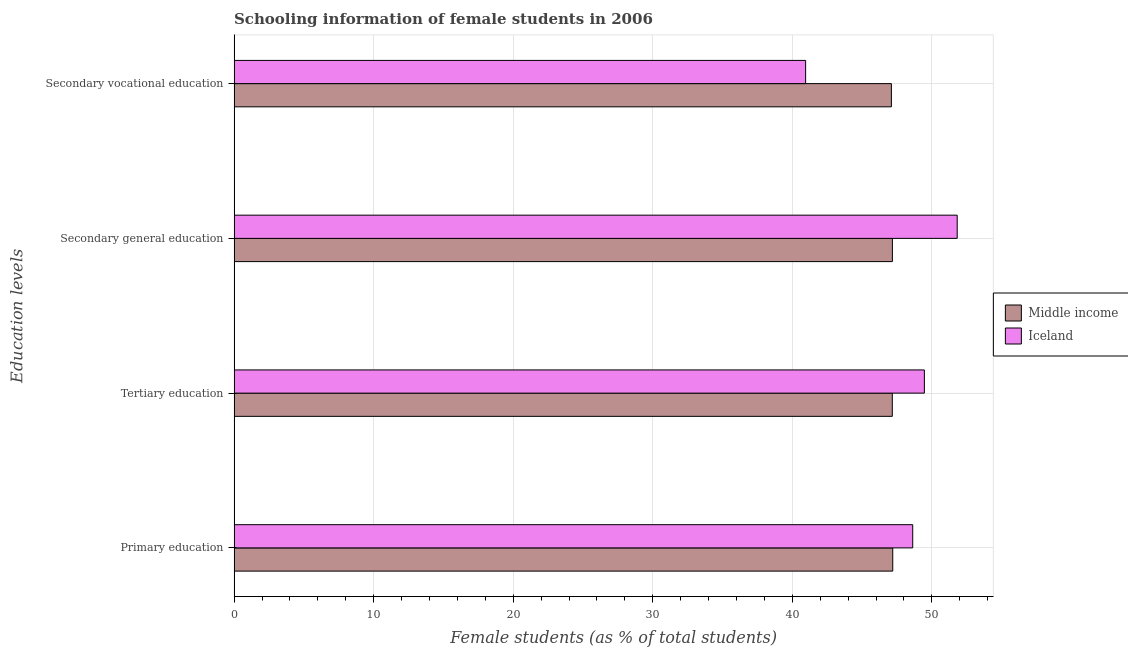How many different coloured bars are there?
Offer a very short reply. 2. Are the number of bars on each tick of the Y-axis equal?
Your answer should be very brief. Yes. How many bars are there on the 2nd tick from the top?
Give a very brief answer. 2. How many bars are there on the 3rd tick from the bottom?
Make the answer very short. 2. What is the percentage of female students in secondary education in Iceland?
Keep it short and to the point. 51.81. Across all countries, what is the maximum percentage of female students in secondary vocational education?
Offer a very short reply. 47.1. Across all countries, what is the minimum percentage of female students in secondary vocational education?
Ensure brevity in your answer.  40.95. What is the total percentage of female students in secondary vocational education in the graph?
Keep it short and to the point. 88.05. What is the difference between the percentage of female students in secondary vocational education in Iceland and that in Middle income?
Offer a terse response. -6.15. What is the difference between the percentage of female students in tertiary education in Middle income and the percentage of female students in secondary vocational education in Iceland?
Keep it short and to the point. 6.21. What is the average percentage of female students in primary education per country?
Make the answer very short. 47.91. What is the difference between the percentage of female students in primary education and percentage of female students in secondary education in Iceland?
Provide a succinct answer. -3.19. What is the ratio of the percentage of female students in secondary education in Iceland to that in Middle income?
Offer a terse response. 1.1. What is the difference between the highest and the second highest percentage of female students in secondary vocational education?
Your response must be concise. 6.15. What is the difference between the highest and the lowest percentage of female students in tertiary education?
Make the answer very short. 2.3. In how many countries, is the percentage of female students in tertiary education greater than the average percentage of female students in tertiary education taken over all countries?
Your answer should be compact. 1. Is it the case that in every country, the sum of the percentage of female students in primary education and percentage of female students in secondary education is greater than the sum of percentage of female students in tertiary education and percentage of female students in secondary vocational education?
Your answer should be compact. No. Is it the case that in every country, the sum of the percentage of female students in primary education and percentage of female students in tertiary education is greater than the percentage of female students in secondary education?
Your answer should be compact. Yes. How many bars are there?
Your answer should be very brief. 8. How many countries are there in the graph?
Provide a succinct answer. 2. Are the values on the major ticks of X-axis written in scientific E-notation?
Offer a very short reply. No. Does the graph contain any zero values?
Offer a terse response. No. How are the legend labels stacked?
Provide a succinct answer. Vertical. What is the title of the graph?
Your response must be concise. Schooling information of female students in 2006. Does "United Arab Emirates" appear as one of the legend labels in the graph?
Keep it short and to the point. No. What is the label or title of the X-axis?
Your response must be concise. Female students (as % of total students). What is the label or title of the Y-axis?
Provide a succinct answer. Education levels. What is the Female students (as % of total students) in Middle income in Primary education?
Your answer should be very brief. 47.2. What is the Female students (as % of total students) of Iceland in Primary education?
Make the answer very short. 48.63. What is the Female students (as % of total students) of Middle income in Tertiary education?
Your answer should be very brief. 47.16. What is the Female students (as % of total students) in Iceland in Tertiary education?
Your response must be concise. 49.46. What is the Female students (as % of total students) in Middle income in Secondary general education?
Provide a short and direct response. 47.17. What is the Female students (as % of total students) in Iceland in Secondary general education?
Offer a terse response. 51.81. What is the Female students (as % of total students) in Middle income in Secondary vocational education?
Keep it short and to the point. 47.1. What is the Female students (as % of total students) in Iceland in Secondary vocational education?
Make the answer very short. 40.95. Across all Education levels, what is the maximum Female students (as % of total students) in Middle income?
Your answer should be very brief. 47.2. Across all Education levels, what is the maximum Female students (as % of total students) of Iceland?
Provide a short and direct response. 51.81. Across all Education levels, what is the minimum Female students (as % of total students) in Middle income?
Make the answer very short. 47.1. Across all Education levels, what is the minimum Female students (as % of total students) in Iceland?
Give a very brief answer. 40.95. What is the total Female students (as % of total students) in Middle income in the graph?
Give a very brief answer. 188.63. What is the total Female students (as % of total students) in Iceland in the graph?
Provide a short and direct response. 190.86. What is the difference between the Female students (as % of total students) in Middle income in Primary education and that in Tertiary education?
Your answer should be compact. 0.03. What is the difference between the Female students (as % of total students) of Iceland in Primary education and that in Tertiary education?
Provide a short and direct response. -0.84. What is the difference between the Female students (as % of total students) in Middle income in Primary education and that in Secondary general education?
Ensure brevity in your answer.  0.03. What is the difference between the Female students (as % of total students) in Iceland in Primary education and that in Secondary general education?
Provide a succinct answer. -3.19. What is the difference between the Female students (as % of total students) of Middle income in Primary education and that in Secondary vocational education?
Keep it short and to the point. 0.1. What is the difference between the Female students (as % of total students) in Iceland in Primary education and that in Secondary vocational education?
Make the answer very short. 7.67. What is the difference between the Female students (as % of total students) in Middle income in Tertiary education and that in Secondary general education?
Your answer should be compact. -0.01. What is the difference between the Female students (as % of total students) in Iceland in Tertiary education and that in Secondary general education?
Provide a succinct answer. -2.35. What is the difference between the Female students (as % of total students) in Middle income in Tertiary education and that in Secondary vocational education?
Give a very brief answer. 0.06. What is the difference between the Female students (as % of total students) in Iceland in Tertiary education and that in Secondary vocational education?
Provide a succinct answer. 8.51. What is the difference between the Female students (as % of total students) of Middle income in Secondary general education and that in Secondary vocational education?
Offer a very short reply. 0.07. What is the difference between the Female students (as % of total students) of Iceland in Secondary general education and that in Secondary vocational education?
Offer a very short reply. 10.86. What is the difference between the Female students (as % of total students) in Middle income in Primary education and the Female students (as % of total students) in Iceland in Tertiary education?
Offer a very short reply. -2.27. What is the difference between the Female students (as % of total students) of Middle income in Primary education and the Female students (as % of total students) of Iceland in Secondary general education?
Provide a succinct answer. -4.62. What is the difference between the Female students (as % of total students) in Middle income in Primary education and the Female students (as % of total students) in Iceland in Secondary vocational education?
Provide a short and direct response. 6.24. What is the difference between the Female students (as % of total students) in Middle income in Tertiary education and the Female students (as % of total students) in Iceland in Secondary general education?
Your response must be concise. -4.65. What is the difference between the Female students (as % of total students) of Middle income in Tertiary education and the Female students (as % of total students) of Iceland in Secondary vocational education?
Offer a terse response. 6.21. What is the difference between the Female students (as % of total students) of Middle income in Secondary general education and the Female students (as % of total students) of Iceland in Secondary vocational education?
Your answer should be very brief. 6.22. What is the average Female students (as % of total students) in Middle income per Education levels?
Provide a short and direct response. 47.16. What is the average Female students (as % of total students) in Iceland per Education levels?
Provide a succinct answer. 47.71. What is the difference between the Female students (as % of total students) of Middle income and Female students (as % of total students) of Iceland in Primary education?
Your answer should be very brief. -1.43. What is the difference between the Female students (as % of total students) of Middle income and Female students (as % of total students) of Iceland in Tertiary education?
Provide a short and direct response. -2.3. What is the difference between the Female students (as % of total students) in Middle income and Female students (as % of total students) in Iceland in Secondary general education?
Ensure brevity in your answer.  -4.64. What is the difference between the Female students (as % of total students) in Middle income and Female students (as % of total students) in Iceland in Secondary vocational education?
Provide a short and direct response. 6.15. What is the ratio of the Female students (as % of total students) of Middle income in Primary education to that in Tertiary education?
Give a very brief answer. 1. What is the ratio of the Female students (as % of total students) in Iceland in Primary education to that in Tertiary education?
Ensure brevity in your answer.  0.98. What is the ratio of the Female students (as % of total students) in Iceland in Primary education to that in Secondary general education?
Your response must be concise. 0.94. What is the ratio of the Female students (as % of total students) in Middle income in Primary education to that in Secondary vocational education?
Provide a short and direct response. 1. What is the ratio of the Female students (as % of total students) of Iceland in Primary education to that in Secondary vocational education?
Give a very brief answer. 1.19. What is the ratio of the Female students (as % of total students) of Iceland in Tertiary education to that in Secondary general education?
Offer a very short reply. 0.95. What is the ratio of the Female students (as % of total students) of Middle income in Tertiary education to that in Secondary vocational education?
Provide a short and direct response. 1. What is the ratio of the Female students (as % of total students) of Iceland in Tertiary education to that in Secondary vocational education?
Provide a short and direct response. 1.21. What is the ratio of the Female students (as % of total students) of Iceland in Secondary general education to that in Secondary vocational education?
Make the answer very short. 1.27. What is the difference between the highest and the second highest Female students (as % of total students) in Middle income?
Keep it short and to the point. 0.03. What is the difference between the highest and the second highest Female students (as % of total students) in Iceland?
Offer a terse response. 2.35. What is the difference between the highest and the lowest Female students (as % of total students) of Middle income?
Offer a terse response. 0.1. What is the difference between the highest and the lowest Female students (as % of total students) in Iceland?
Make the answer very short. 10.86. 